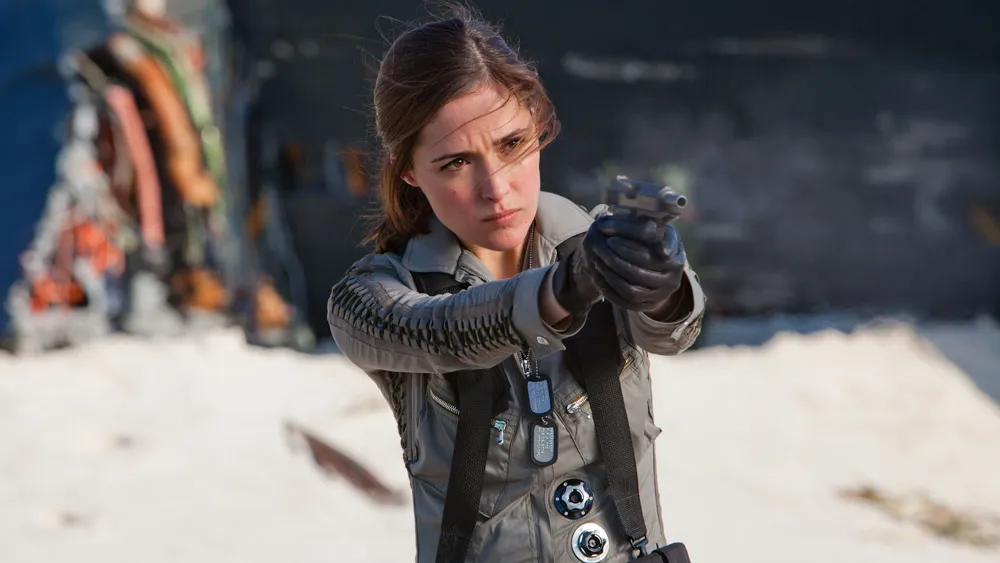What do you see happening in this image? In the image, an actress is captured in a dramatic moment from a movie scene. She stands against a stark backdrop, her figure providing a striking contrast. Clad in a detailed gray jacket adorned with unique metallic accents and a harness, she exudes an air of determination and readiness. Her right hand grips a gun, its barrel aimed towards the left side of the frame, suggesting an unseen threat or target. Her expression is serious, eyes focused and intent, reflecting the gravity of the situation she’s in within the narrative of the movie. 